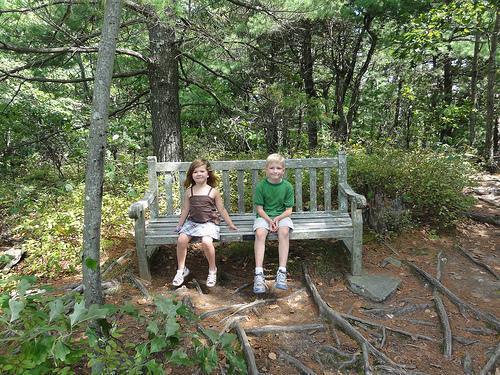How many benches are outside?
Give a very brief answer. 1. 